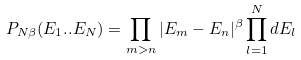Convert formula to latex. <formula><loc_0><loc_0><loc_500><loc_500>P _ { N \beta } ( E _ { 1 } . . E _ { N } ) = \prod _ { m > n } | E _ { m } - E _ { n } | ^ { \beta } \prod _ { l = 1 } ^ { N } d E _ { l }</formula> 